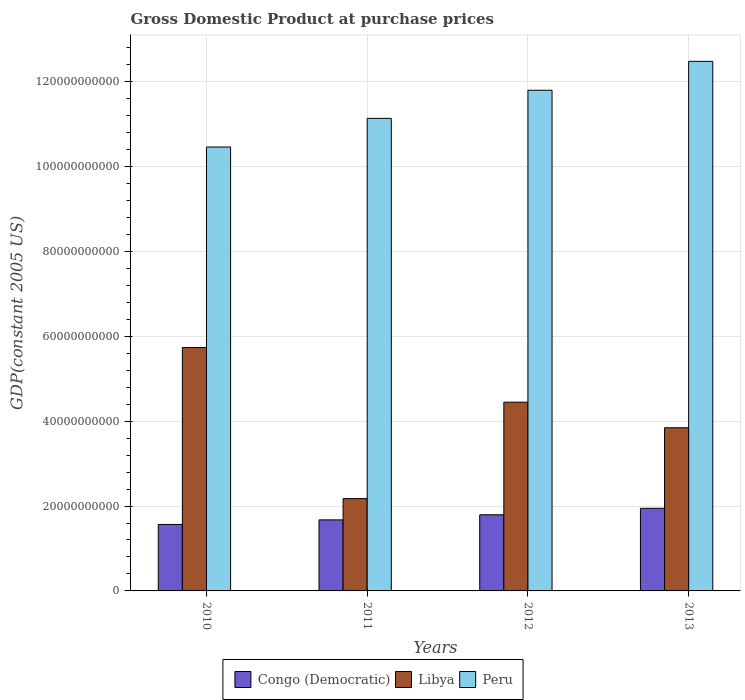How many groups of bars are there?
Ensure brevity in your answer.  4. Are the number of bars per tick equal to the number of legend labels?
Offer a very short reply. Yes. Are the number of bars on each tick of the X-axis equal?
Provide a short and direct response. Yes. How many bars are there on the 1st tick from the left?
Your answer should be very brief. 3. How many bars are there on the 2nd tick from the right?
Ensure brevity in your answer.  3. In how many cases, is the number of bars for a given year not equal to the number of legend labels?
Your answer should be compact. 0. What is the GDP at purchase prices in Peru in 2013?
Offer a terse response. 1.25e+11. Across all years, what is the maximum GDP at purchase prices in Libya?
Provide a short and direct response. 5.74e+1. Across all years, what is the minimum GDP at purchase prices in Peru?
Keep it short and to the point. 1.05e+11. In which year was the GDP at purchase prices in Congo (Democratic) maximum?
Your answer should be very brief. 2013. In which year was the GDP at purchase prices in Congo (Democratic) minimum?
Keep it short and to the point. 2010. What is the total GDP at purchase prices in Peru in the graph?
Make the answer very short. 4.59e+11. What is the difference between the GDP at purchase prices in Congo (Democratic) in 2010 and that in 2013?
Give a very brief answer. -3.80e+09. What is the difference between the GDP at purchase prices in Libya in 2010 and the GDP at purchase prices in Peru in 2012?
Offer a very short reply. -6.06e+1. What is the average GDP at purchase prices in Peru per year?
Ensure brevity in your answer.  1.15e+11. In the year 2011, what is the difference between the GDP at purchase prices in Libya and GDP at purchase prices in Peru?
Keep it short and to the point. -8.96e+1. In how many years, is the GDP at purchase prices in Peru greater than 20000000000 US$?
Your answer should be compact. 4. What is the ratio of the GDP at purchase prices in Peru in 2011 to that in 2013?
Make the answer very short. 0.89. Is the difference between the GDP at purchase prices in Libya in 2011 and 2013 greater than the difference between the GDP at purchase prices in Peru in 2011 and 2013?
Ensure brevity in your answer.  No. What is the difference between the highest and the second highest GDP at purchase prices in Libya?
Make the answer very short. 1.29e+1. What is the difference between the highest and the lowest GDP at purchase prices in Peru?
Your response must be concise. 2.02e+1. Is the sum of the GDP at purchase prices in Peru in 2010 and 2011 greater than the maximum GDP at purchase prices in Libya across all years?
Provide a succinct answer. Yes. What does the 1st bar from the left in 2013 represents?
Ensure brevity in your answer.  Congo (Democratic). Are the values on the major ticks of Y-axis written in scientific E-notation?
Make the answer very short. No. What is the title of the graph?
Offer a terse response. Gross Domestic Product at purchase prices. Does "Pakistan" appear as one of the legend labels in the graph?
Your answer should be very brief. No. What is the label or title of the Y-axis?
Your answer should be very brief. GDP(constant 2005 US). What is the GDP(constant 2005 US) of Congo (Democratic) in 2010?
Offer a very short reply. 1.57e+1. What is the GDP(constant 2005 US) in Libya in 2010?
Your response must be concise. 5.74e+1. What is the GDP(constant 2005 US) in Peru in 2010?
Your response must be concise. 1.05e+11. What is the GDP(constant 2005 US) in Congo (Democratic) in 2011?
Your response must be concise. 1.67e+1. What is the GDP(constant 2005 US) in Libya in 2011?
Your answer should be very brief. 2.17e+1. What is the GDP(constant 2005 US) in Peru in 2011?
Make the answer very short. 1.11e+11. What is the GDP(constant 2005 US) in Congo (Democratic) in 2012?
Offer a very short reply. 1.79e+1. What is the GDP(constant 2005 US) in Libya in 2012?
Ensure brevity in your answer.  4.45e+1. What is the GDP(constant 2005 US) of Peru in 2012?
Make the answer very short. 1.18e+11. What is the GDP(constant 2005 US) in Congo (Democratic) in 2013?
Keep it short and to the point. 1.95e+1. What is the GDP(constant 2005 US) in Libya in 2013?
Your answer should be compact. 3.84e+1. What is the GDP(constant 2005 US) of Peru in 2013?
Make the answer very short. 1.25e+11. Across all years, what is the maximum GDP(constant 2005 US) of Congo (Democratic)?
Your answer should be very brief. 1.95e+1. Across all years, what is the maximum GDP(constant 2005 US) in Libya?
Give a very brief answer. 5.74e+1. Across all years, what is the maximum GDP(constant 2005 US) in Peru?
Provide a short and direct response. 1.25e+11. Across all years, what is the minimum GDP(constant 2005 US) of Congo (Democratic)?
Make the answer very short. 1.57e+1. Across all years, what is the minimum GDP(constant 2005 US) in Libya?
Your answer should be compact. 2.17e+1. Across all years, what is the minimum GDP(constant 2005 US) in Peru?
Make the answer very short. 1.05e+11. What is the total GDP(constant 2005 US) in Congo (Democratic) in the graph?
Keep it short and to the point. 6.98e+1. What is the total GDP(constant 2005 US) in Libya in the graph?
Make the answer very short. 1.62e+11. What is the total GDP(constant 2005 US) in Peru in the graph?
Ensure brevity in your answer.  4.59e+11. What is the difference between the GDP(constant 2005 US) of Congo (Democratic) in 2010 and that in 2011?
Your answer should be compact. -1.08e+09. What is the difference between the GDP(constant 2005 US) of Libya in 2010 and that in 2011?
Make the answer very short. 3.56e+1. What is the difference between the GDP(constant 2005 US) in Peru in 2010 and that in 2011?
Provide a succinct answer. -6.75e+09. What is the difference between the GDP(constant 2005 US) of Congo (Democratic) in 2010 and that in 2012?
Your response must be concise. -2.27e+09. What is the difference between the GDP(constant 2005 US) in Libya in 2010 and that in 2012?
Make the answer very short. 1.29e+1. What is the difference between the GDP(constant 2005 US) in Peru in 2010 and that in 2012?
Your answer should be very brief. -1.34e+1. What is the difference between the GDP(constant 2005 US) of Congo (Democratic) in 2010 and that in 2013?
Your answer should be compact. -3.80e+09. What is the difference between the GDP(constant 2005 US) of Libya in 2010 and that in 2013?
Make the answer very short. 1.89e+1. What is the difference between the GDP(constant 2005 US) of Peru in 2010 and that in 2013?
Your response must be concise. -2.02e+1. What is the difference between the GDP(constant 2005 US) of Congo (Democratic) in 2011 and that in 2012?
Your answer should be compact. -1.20e+09. What is the difference between the GDP(constant 2005 US) in Libya in 2011 and that in 2012?
Your answer should be very brief. -2.27e+1. What is the difference between the GDP(constant 2005 US) of Peru in 2011 and that in 2012?
Keep it short and to the point. -6.63e+09. What is the difference between the GDP(constant 2005 US) in Congo (Democratic) in 2011 and that in 2013?
Keep it short and to the point. -2.72e+09. What is the difference between the GDP(constant 2005 US) of Libya in 2011 and that in 2013?
Your answer should be very brief. -1.67e+1. What is the difference between the GDP(constant 2005 US) in Peru in 2011 and that in 2013?
Provide a succinct answer. -1.34e+1. What is the difference between the GDP(constant 2005 US) of Congo (Democratic) in 2012 and that in 2013?
Keep it short and to the point. -1.53e+09. What is the difference between the GDP(constant 2005 US) of Libya in 2012 and that in 2013?
Your answer should be compact. 6.03e+09. What is the difference between the GDP(constant 2005 US) in Peru in 2012 and that in 2013?
Offer a terse response. -6.81e+09. What is the difference between the GDP(constant 2005 US) in Congo (Democratic) in 2010 and the GDP(constant 2005 US) in Libya in 2011?
Your response must be concise. -6.08e+09. What is the difference between the GDP(constant 2005 US) in Congo (Democratic) in 2010 and the GDP(constant 2005 US) in Peru in 2011?
Your answer should be compact. -9.57e+1. What is the difference between the GDP(constant 2005 US) in Libya in 2010 and the GDP(constant 2005 US) in Peru in 2011?
Give a very brief answer. -5.40e+1. What is the difference between the GDP(constant 2005 US) of Congo (Democratic) in 2010 and the GDP(constant 2005 US) of Libya in 2012?
Provide a short and direct response. -2.88e+1. What is the difference between the GDP(constant 2005 US) in Congo (Democratic) in 2010 and the GDP(constant 2005 US) in Peru in 2012?
Keep it short and to the point. -1.02e+11. What is the difference between the GDP(constant 2005 US) in Libya in 2010 and the GDP(constant 2005 US) in Peru in 2012?
Your answer should be very brief. -6.06e+1. What is the difference between the GDP(constant 2005 US) in Congo (Democratic) in 2010 and the GDP(constant 2005 US) in Libya in 2013?
Make the answer very short. -2.28e+1. What is the difference between the GDP(constant 2005 US) in Congo (Democratic) in 2010 and the GDP(constant 2005 US) in Peru in 2013?
Provide a short and direct response. -1.09e+11. What is the difference between the GDP(constant 2005 US) of Libya in 2010 and the GDP(constant 2005 US) of Peru in 2013?
Keep it short and to the point. -6.74e+1. What is the difference between the GDP(constant 2005 US) of Congo (Democratic) in 2011 and the GDP(constant 2005 US) of Libya in 2012?
Ensure brevity in your answer.  -2.77e+1. What is the difference between the GDP(constant 2005 US) of Congo (Democratic) in 2011 and the GDP(constant 2005 US) of Peru in 2012?
Keep it short and to the point. -1.01e+11. What is the difference between the GDP(constant 2005 US) in Libya in 2011 and the GDP(constant 2005 US) in Peru in 2012?
Your response must be concise. -9.62e+1. What is the difference between the GDP(constant 2005 US) in Congo (Democratic) in 2011 and the GDP(constant 2005 US) in Libya in 2013?
Provide a succinct answer. -2.17e+1. What is the difference between the GDP(constant 2005 US) in Congo (Democratic) in 2011 and the GDP(constant 2005 US) in Peru in 2013?
Provide a succinct answer. -1.08e+11. What is the difference between the GDP(constant 2005 US) of Libya in 2011 and the GDP(constant 2005 US) of Peru in 2013?
Make the answer very short. -1.03e+11. What is the difference between the GDP(constant 2005 US) of Congo (Democratic) in 2012 and the GDP(constant 2005 US) of Libya in 2013?
Provide a succinct answer. -2.05e+1. What is the difference between the GDP(constant 2005 US) in Congo (Democratic) in 2012 and the GDP(constant 2005 US) in Peru in 2013?
Your response must be concise. -1.07e+11. What is the difference between the GDP(constant 2005 US) in Libya in 2012 and the GDP(constant 2005 US) in Peru in 2013?
Make the answer very short. -8.03e+1. What is the average GDP(constant 2005 US) of Congo (Democratic) per year?
Your response must be concise. 1.75e+1. What is the average GDP(constant 2005 US) of Libya per year?
Ensure brevity in your answer.  4.05e+1. What is the average GDP(constant 2005 US) of Peru per year?
Your answer should be very brief. 1.15e+11. In the year 2010, what is the difference between the GDP(constant 2005 US) of Congo (Democratic) and GDP(constant 2005 US) of Libya?
Your answer should be very brief. -4.17e+1. In the year 2010, what is the difference between the GDP(constant 2005 US) in Congo (Democratic) and GDP(constant 2005 US) in Peru?
Make the answer very short. -8.89e+1. In the year 2010, what is the difference between the GDP(constant 2005 US) of Libya and GDP(constant 2005 US) of Peru?
Offer a terse response. -4.73e+1. In the year 2011, what is the difference between the GDP(constant 2005 US) in Congo (Democratic) and GDP(constant 2005 US) in Libya?
Keep it short and to the point. -5.01e+09. In the year 2011, what is the difference between the GDP(constant 2005 US) in Congo (Democratic) and GDP(constant 2005 US) in Peru?
Your response must be concise. -9.46e+1. In the year 2011, what is the difference between the GDP(constant 2005 US) in Libya and GDP(constant 2005 US) in Peru?
Offer a terse response. -8.96e+1. In the year 2012, what is the difference between the GDP(constant 2005 US) in Congo (Democratic) and GDP(constant 2005 US) in Libya?
Make the answer very short. -2.65e+1. In the year 2012, what is the difference between the GDP(constant 2005 US) of Congo (Democratic) and GDP(constant 2005 US) of Peru?
Offer a very short reply. -1.00e+11. In the year 2012, what is the difference between the GDP(constant 2005 US) of Libya and GDP(constant 2005 US) of Peru?
Your answer should be very brief. -7.35e+1. In the year 2013, what is the difference between the GDP(constant 2005 US) of Congo (Democratic) and GDP(constant 2005 US) of Libya?
Give a very brief answer. -1.90e+1. In the year 2013, what is the difference between the GDP(constant 2005 US) in Congo (Democratic) and GDP(constant 2005 US) in Peru?
Keep it short and to the point. -1.05e+11. In the year 2013, what is the difference between the GDP(constant 2005 US) in Libya and GDP(constant 2005 US) in Peru?
Provide a short and direct response. -8.63e+1. What is the ratio of the GDP(constant 2005 US) of Congo (Democratic) in 2010 to that in 2011?
Make the answer very short. 0.94. What is the ratio of the GDP(constant 2005 US) in Libya in 2010 to that in 2011?
Offer a very short reply. 2.64. What is the ratio of the GDP(constant 2005 US) of Peru in 2010 to that in 2011?
Provide a succinct answer. 0.94. What is the ratio of the GDP(constant 2005 US) of Congo (Democratic) in 2010 to that in 2012?
Give a very brief answer. 0.87. What is the ratio of the GDP(constant 2005 US) in Libya in 2010 to that in 2012?
Offer a terse response. 1.29. What is the ratio of the GDP(constant 2005 US) in Peru in 2010 to that in 2012?
Keep it short and to the point. 0.89. What is the ratio of the GDP(constant 2005 US) of Congo (Democratic) in 2010 to that in 2013?
Provide a short and direct response. 0.8. What is the ratio of the GDP(constant 2005 US) of Libya in 2010 to that in 2013?
Your answer should be compact. 1.49. What is the ratio of the GDP(constant 2005 US) in Peru in 2010 to that in 2013?
Offer a very short reply. 0.84. What is the ratio of the GDP(constant 2005 US) in Congo (Democratic) in 2011 to that in 2012?
Your response must be concise. 0.93. What is the ratio of the GDP(constant 2005 US) in Libya in 2011 to that in 2012?
Provide a succinct answer. 0.49. What is the ratio of the GDP(constant 2005 US) of Peru in 2011 to that in 2012?
Offer a terse response. 0.94. What is the ratio of the GDP(constant 2005 US) of Congo (Democratic) in 2011 to that in 2013?
Ensure brevity in your answer.  0.86. What is the ratio of the GDP(constant 2005 US) of Libya in 2011 to that in 2013?
Your response must be concise. 0.57. What is the ratio of the GDP(constant 2005 US) in Peru in 2011 to that in 2013?
Your answer should be very brief. 0.89. What is the ratio of the GDP(constant 2005 US) in Congo (Democratic) in 2012 to that in 2013?
Provide a succinct answer. 0.92. What is the ratio of the GDP(constant 2005 US) in Libya in 2012 to that in 2013?
Give a very brief answer. 1.16. What is the ratio of the GDP(constant 2005 US) of Peru in 2012 to that in 2013?
Ensure brevity in your answer.  0.95. What is the difference between the highest and the second highest GDP(constant 2005 US) in Congo (Democratic)?
Offer a terse response. 1.53e+09. What is the difference between the highest and the second highest GDP(constant 2005 US) of Libya?
Provide a short and direct response. 1.29e+1. What is the difference between the highest and the second highest GDP(constant 2005 US) of Peru?
Offer a terse response. 6.81e+09. What is the difference between the highest and the lowest GDP(constant 2005 US) in Congo (Democratic)?
Provide a succinct answer. 3.80e+09. What is the difference between the highest and the lowest GDP(constant 2005 US) in Libya?
Make the answer very short. 3.56e+1. What is the difference between the highest and the lowest GDP(constant 2005 US) of Peru?
Offer a terse response. 2.02e+1. 